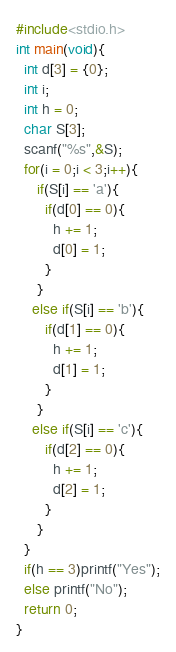Convert code to text. <code><loc_0><loc_0><loc_500><loc_500><_C_>#include<stdio.h>
int main(void){
  int d[3] = {0};
  int i;
  int h = 0;
  char S[3];
  scanf("%s",&S);
  for(i = 0;i < 3;i++){
 	 if(S[i] == 'a'){
       if(d[0] == 0){
         h += 1;
         d[0] = 1;
       }
     }
    else if(S[i] == 'b'){
       if(d[1] == 0){
         h += 1;
         d[1] = 1;
       }
     }
    else if(S[i] == 'c'){
       if(d[2] == 0){
         h += 1;
         d[2] = 1;
       }
     }
  }
  if(h == 3)printf("Yes");
  else printf("No");
  return 0;
}</code> 